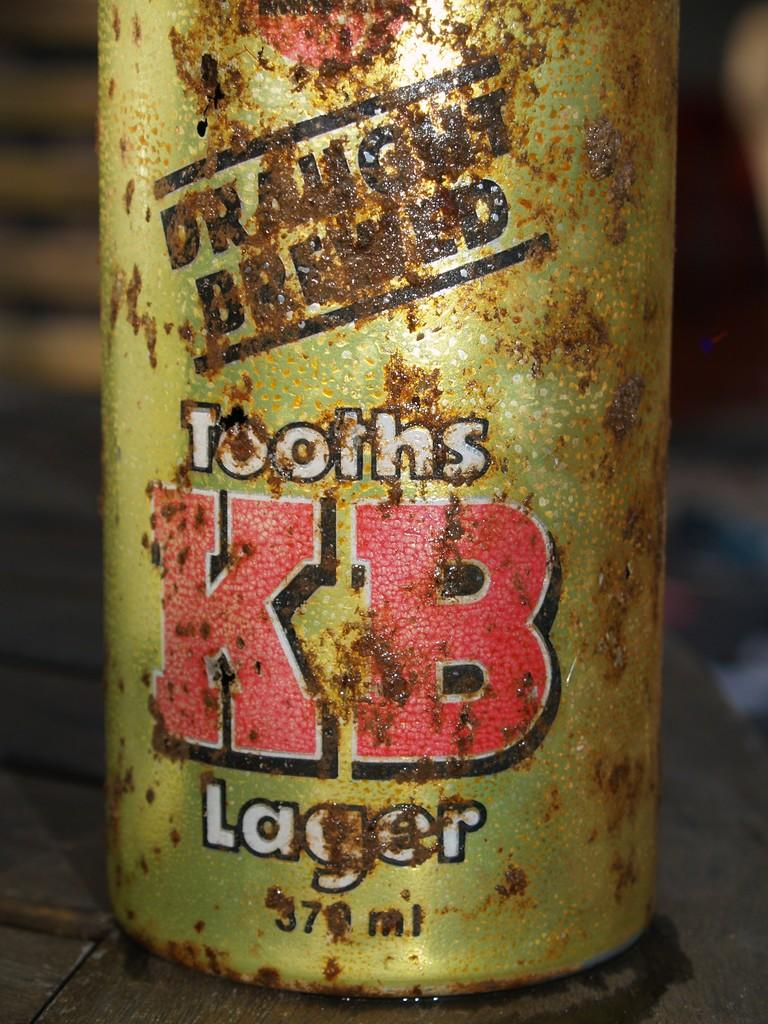What object can be seen in the image? There is a bottle in the image. Where is the bottle located? The bottle is placed on a wooden table. What type of feather is used as apparel in the image? There is no feather or apparel present in the image; it only features a bottle on a wooden table. 